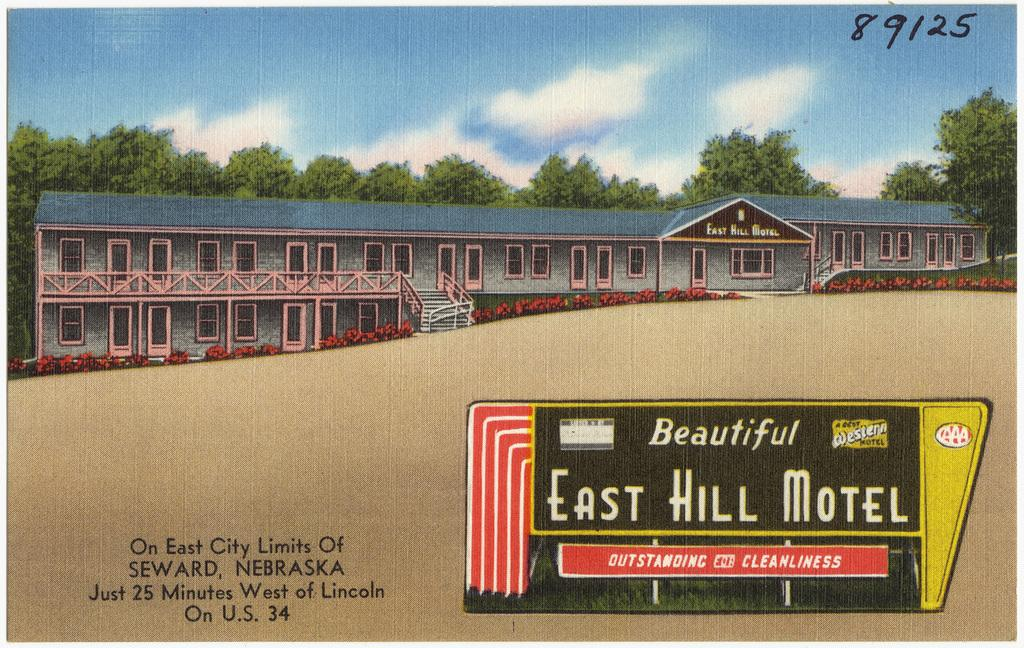<image>
Write a terse but informative summary of the picture. An artists rendering of the East Hill Motel building. 